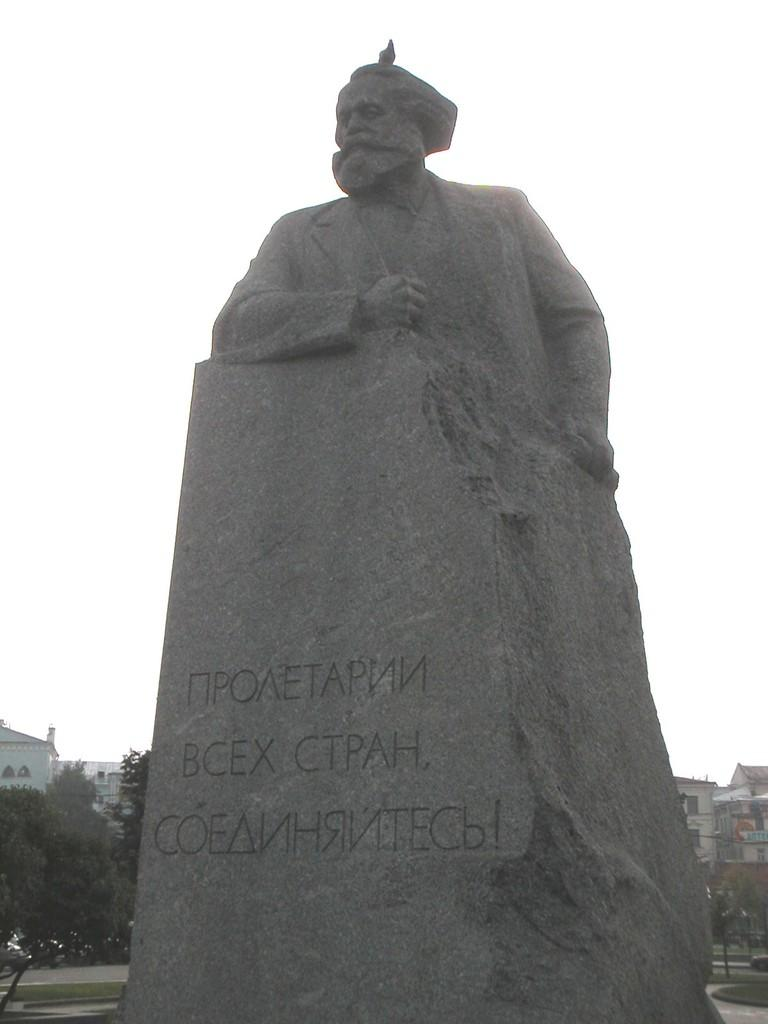What is the main subject in the image? There is a grey statue in the image. What can be seen in the background of the image? Buildings and trees are visible in the background. What is the color of the sky in the image? The sky is white in color. How many eyes does the statue have in the image? The statue is a sculpture and does not have eyes, as it is not a living being. 